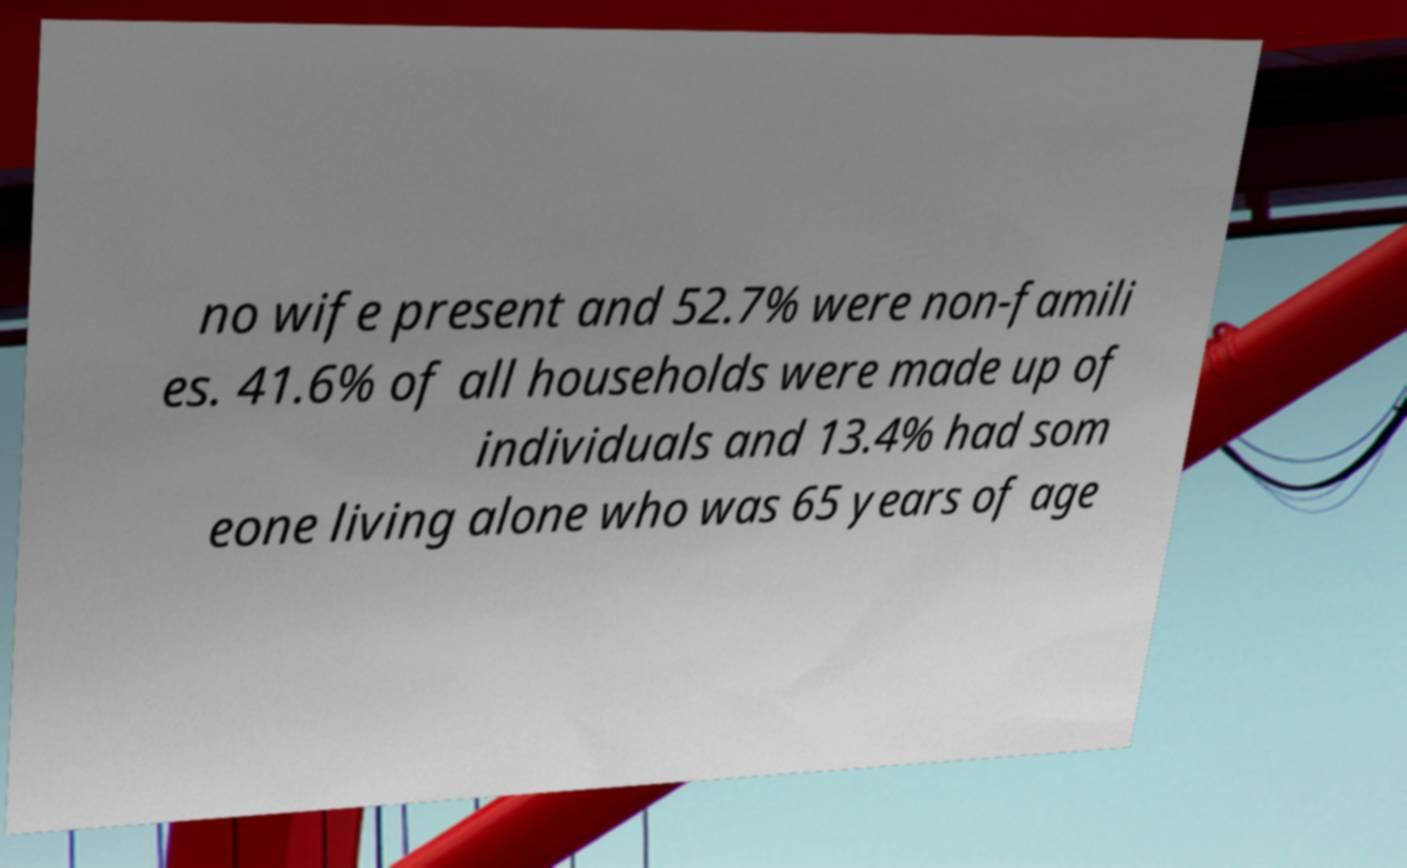There's text embedded in this image that I need extracted. Can you transcribe it verbatim? no wife present and 52.7% were non-famili es. 41.6% of all households were made up of individuals and 13.4% had som eone living alone who was 65 years of age 